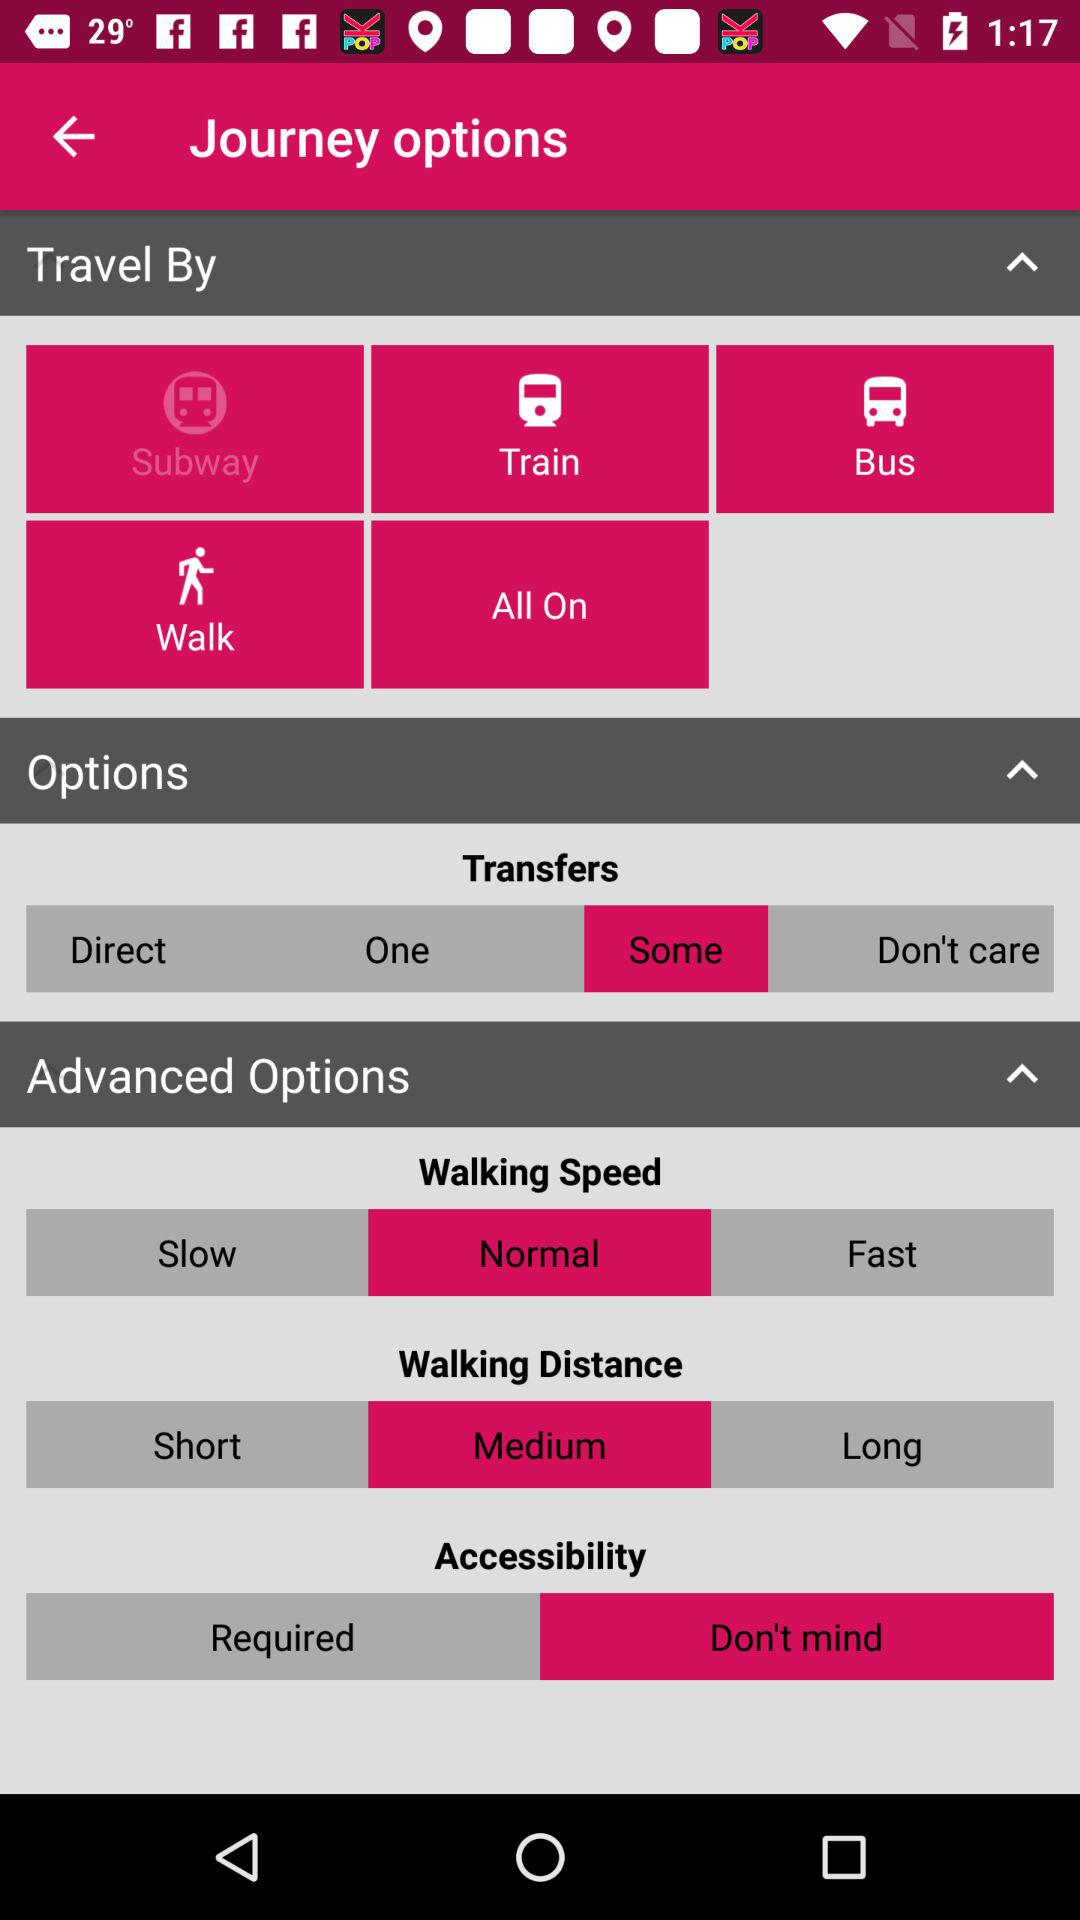What option was selected for transfers? The selected option was some. 